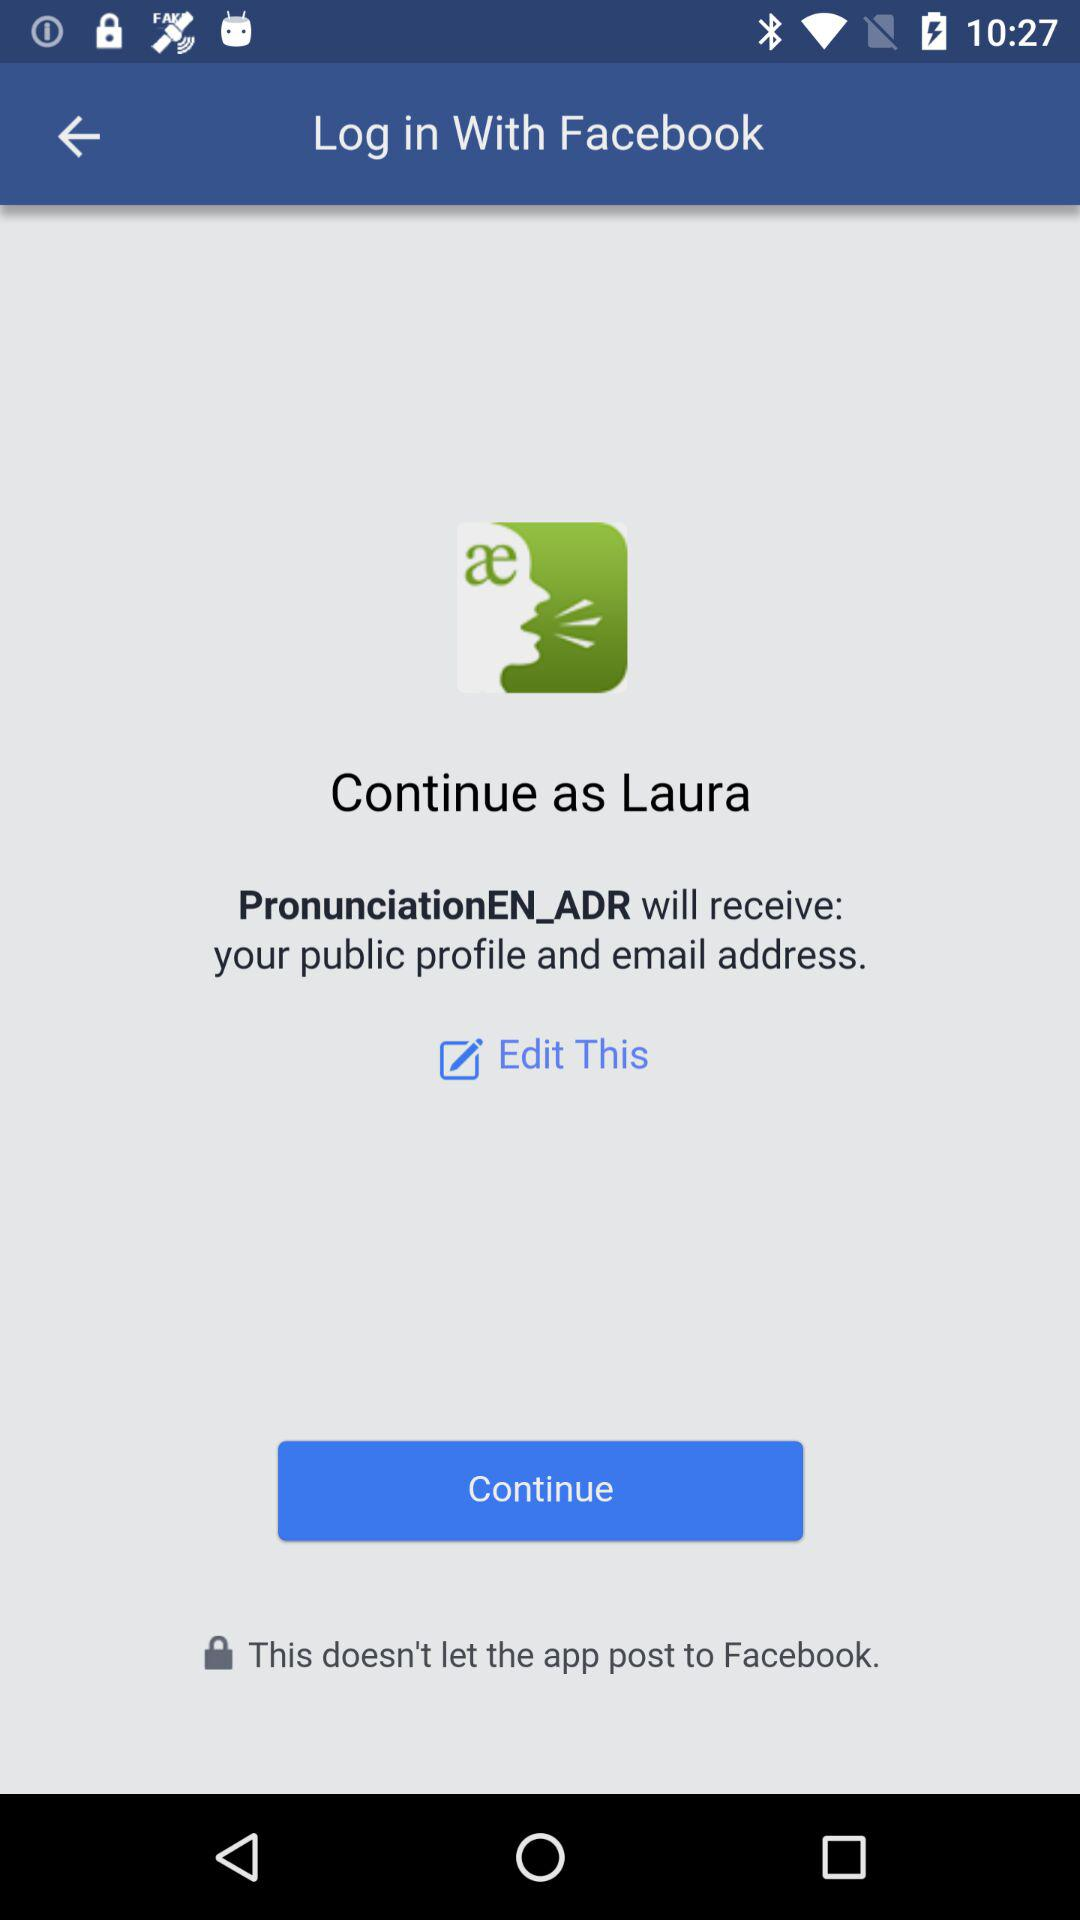What is the login name? The login name is Laura. 